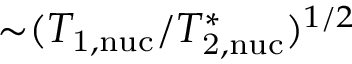Convert formula to latex. <formula><loc_0><loc_0><loc_500><loc_500>{ \sim } ( T _ { 1 , n u c } / T _ { 2 , n u c } ^ { \ast } ) ^ { 1 / 2 }</formula> 